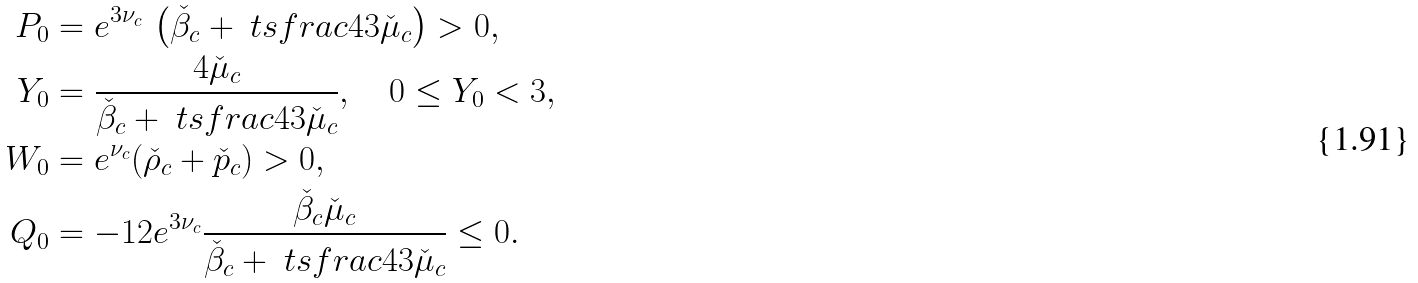<formula> <loc_0><loc_0><loc_500><loc_500>P _ { 0 } & = e ^ { 3 \nu _ { c } } \, \left ( \check { \beta } _ { c } + \ t s f r a c 4 3 \check { \mu } _ { c } \right ) > 0 , \\ Y _ { 0 } & = \frac { 4 \check { \mu } _ { c } } { \check { \beta } _ { c } + \ t s f r a c 4 3 \check { \mu } _ { c } } , \quad 0 \leq Y _ { 0 } < 3 , \\ W _ { 0 } & = e ^ { \nu _ { c } } ( \check { \rho } _ { c } + \check { p } _ { c } ) > 0 , \\ \ Q _ { 0 } & = - 1 2 e ^ { 3 \nu _ { c } } \frac { \check { \beta } _ { c } \check { \mu } _ { c } } { \check { \beta } _ { c } + \ t s f r a c 4 3 \check { \mu } _ { c } } \leq 0 .</formula> 